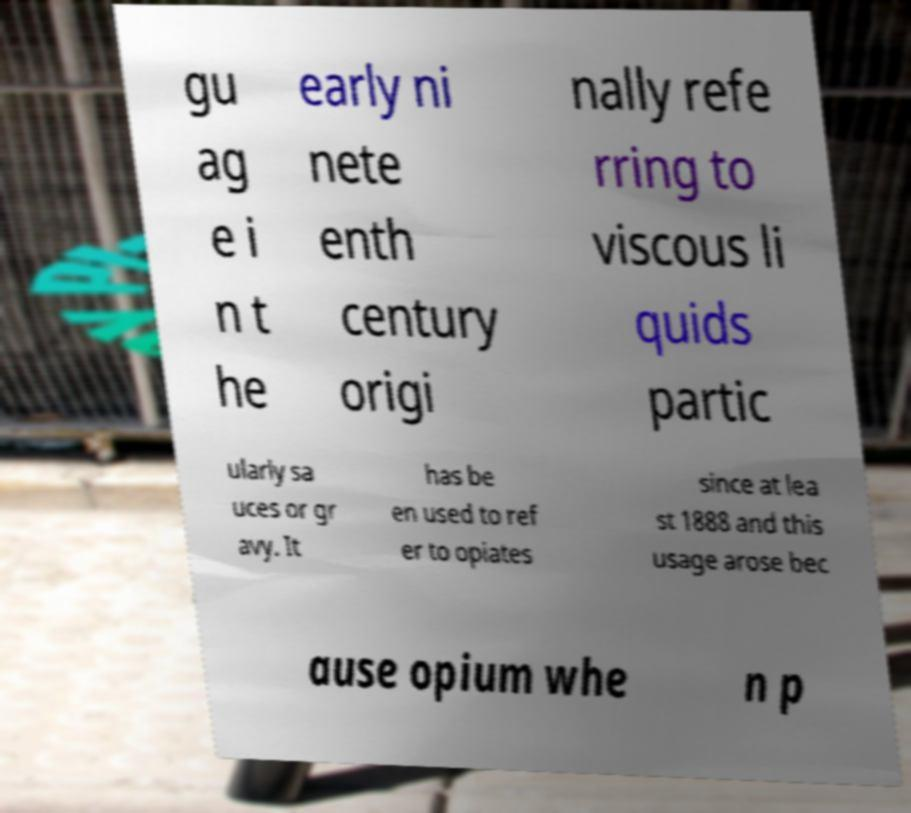For documentation purposes, I need the text within this image transcribed. Could you provide that? gu ag e i n t he early ni nete enth century origi nally refe rring to viscous li quids partic ularly sa uces or gr avy. It has be en used to ref er to opiates since at lea st 1888 and this usage arose bec ause opium whe n p 